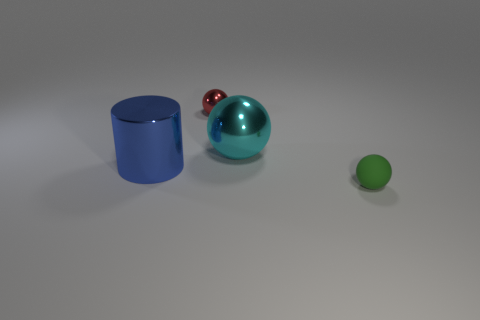Subtract all cyan balls. How many balls are left? 2 Subtract all matte spheres. How many spheres are left? 2 Add 3 green objects. How many objects exist? 7 Subtract 0 cyan cylinders. How many objects are left? 4 Subtract all cylinders. How many objects are left? 3 Subtract 2 balls. How many balls are left? 1 Subtract all gray cylinders. Subtract all cyan blocks. How many cylinders are left? 1 Subtract all cyan cylinders. How many red spheres are left? 1 Subtract all cyan cylinders. Subtract all small objects. How many objects are left? 2 Add 1 balls. How many balls are left? 4 